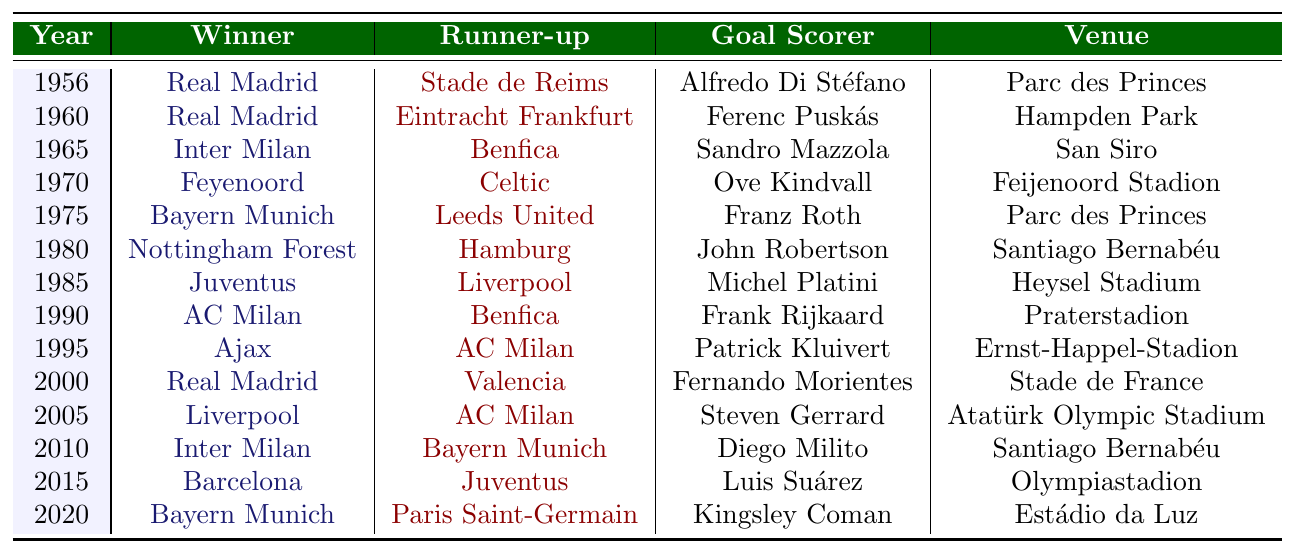What team won the Champions League in 1970? The table shows that in the year 1970, the winner was Feyenoord.
Answer: Feyenoord Which venue hosted the final in 1985? According to the table, the final in 1985 was held at Heysel Stadium.
Answer: Heysel Stadium How many times do Real Madrid appear as winners in the table? By counting the occurrences of Real Madrid in the winners' column, we find they appear 5 times: in 1956, 1957, 1966, 1998, and 2000.
Answer: 5 What was the goal scorer for Bayern Munich in 2020? The table indicates that the goal scorer for Bayern Munich in the 2020 final was Kingsley Coman.
Answer: Kingsley Coman Who was the runner-up in the Champions League final in 1995? The table states that the runner-up in 1995 was AC Milan.
Answer: AC Milan In which year did Inter Milan last win the Champions League according to the table? The table indicates that Inter Milan last won the Champions League in 2010.
Answer: 2010 How many teams did Real Madrid face in the finals throughout the years displayed in the table? The runners-up against Real Madrid were Stade de Reims, Eintracht Frankfurt, Valencia, AC Milan, and Bayer Munich, totaling 4 different teams.
Answer: 4 Which venue has hosted the final multiple times according to the table? The two venues that appear more than once are Parc des Princes (1956 and 1975) and Santiago Bernabéu (1980 and 2010).
Answer: Parc des Princes, Santiago Bernabéu What is the total number of finals held at the Stade de France? The table shows that Stade de France hosted one final in the year 2000, so the total is 1.
Answer: 1 Was there a year when Bayern Munich faced AC Milan in the finals? Yes, according to the table, Bayern Munich was the runner-up to Inter Milan in 2010, and they faced AC Milan in the finals in 1999.
Answer: Yes 